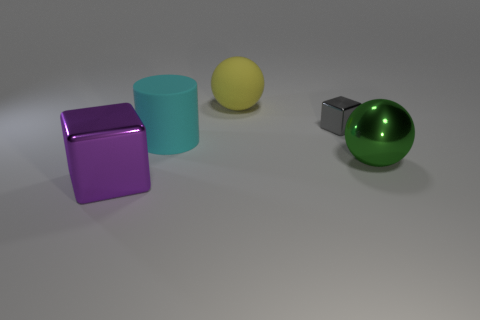Add 2 red objects. How many objects exist? 7 Subtract all cylinders. How many objects are left? 4 Subtract all brown balls. Subtract all blue cylinders. How many balls are left? 2 Subtract all purple cylinders. How many gray cubes are left? 1 Subtract all large yellow cylinders. Subtract all small gray blocks. How many objects are left? 4 Add 4 large cyan objects. How many large cyan objects are left? 5 Add 4 rubber things. How many rubber things exist? 6 Subtract all green balls. How many balls are left? 1 Subtract 0 red cubes. How many objects are left? 5 